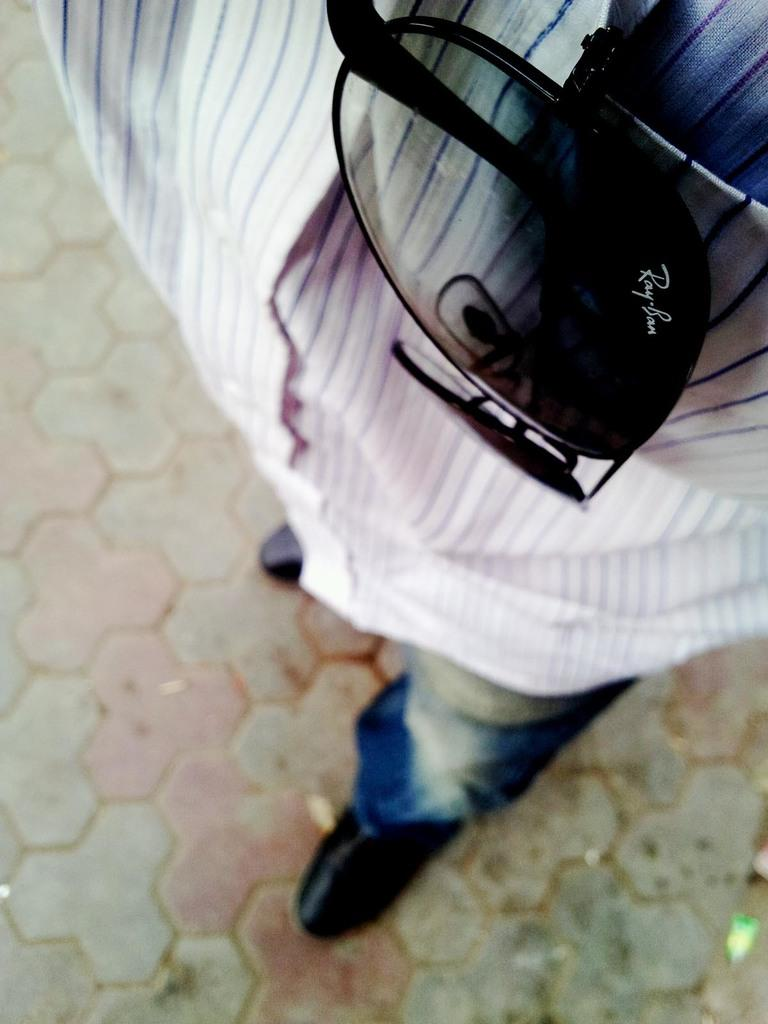What is the main subject of the image? There is a man in the image. What can be found in the man's pocket? The man has sunglasses in his pocket. What type of shoes is the man wearing? The man is wearing black shoes. What type of pants is the man wearing? The man is wearing blue jeans. What type of shirt is the man wearing? The man is wearing a white shirt with blue lines on it. What word is written on the roof in the image? There is no word written on the roof in the image, as there is no roof present in the image. 